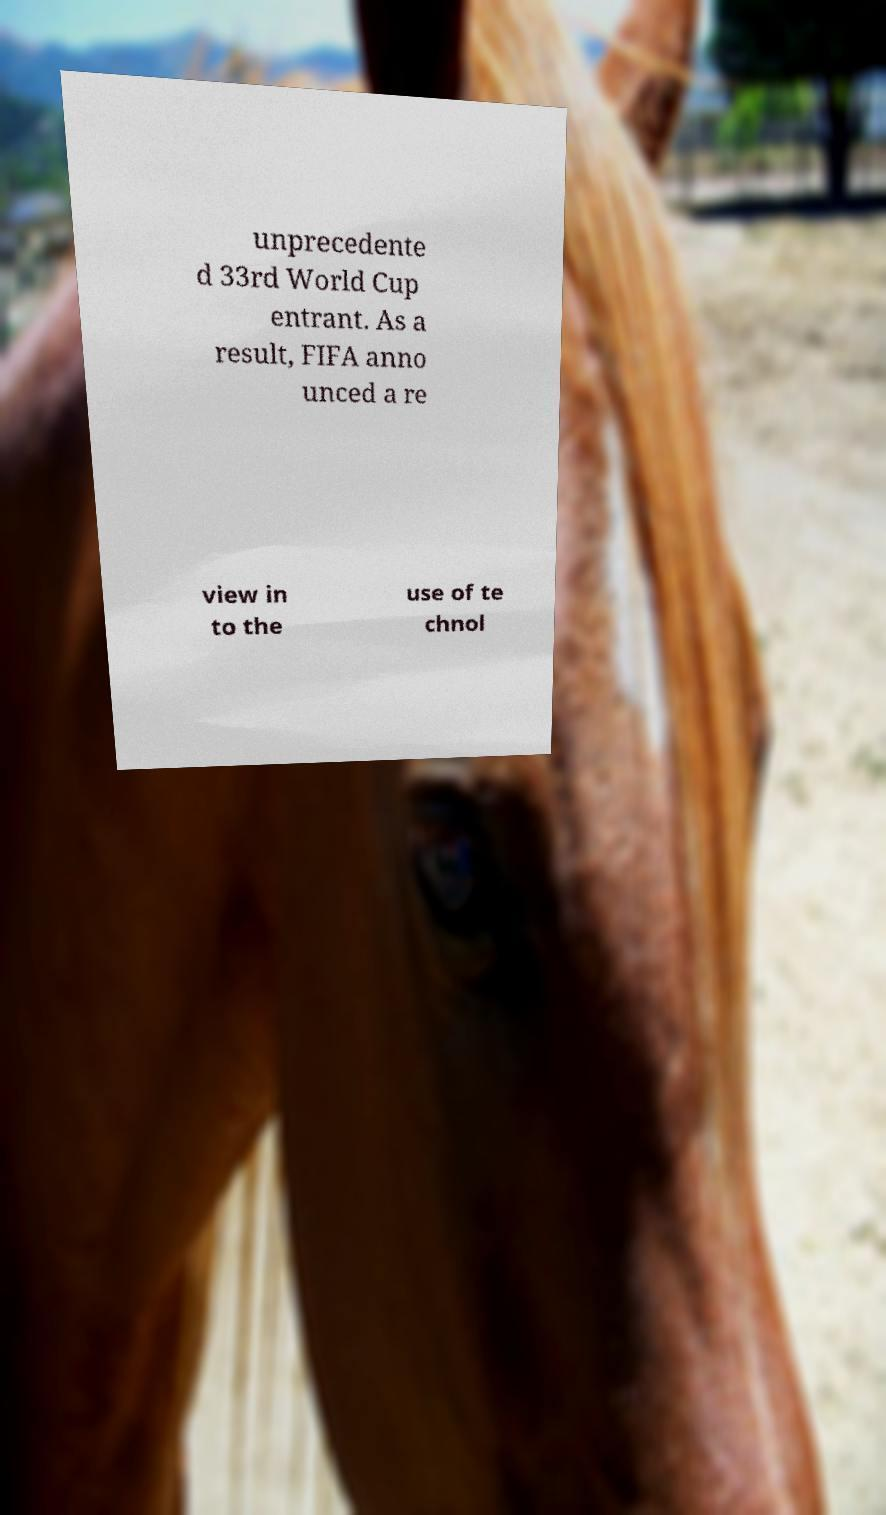Can you read and provide the text displayed in the image?This photo seems to have some interesting text. Can you extract and type it out for me? unprecedente d 33rd World Cup entrant. As a result, FIFA anno unced a re view in to the use of te chnol 